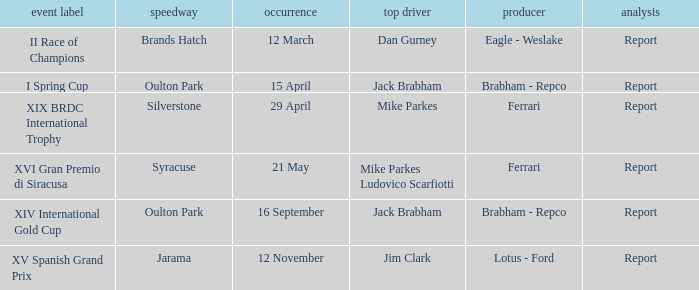What is the circuit held on 15 april? Oulton Park. 